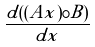<formula> <loc_0><loc_0><loc_500><loc_500>\frac { d ( ( A x ) \circ B ) } { d x }</formula> 